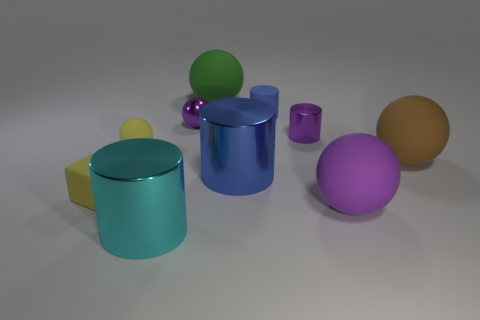There is a small rubber thing that is the same color as the small matte cube; what shape is it?
Give a very brief answer. Sphere. What shape is the tiny yellow thing that is in front of the big metal cylinder right of the large green matte thing?
Make the answer very short. Cube. Is there any other thing that is the same color as the tiny metal cylinder?
Keep it short and to the point. Yes. There is a blue object that is the same material as the green thing; what shape is it?
Provide a short and direct response. Cylinder. How big is the shiny object that is both on the left side of the blue metal object and to the right of the cyan shiny object?
Offer a very short reply. Small. There is a large rubber object on the left side of the big purple matte object; is its shape the same as the purple rubber object?
Keep it short and to the point. Yes. How big is the metal cylinder on the right side of the large metallic thing that is to the right of the tiny purple ball behind the large purple thing?
Ensure brevity in your answer.  Small. What size is the sphere that is the same color as the small cube?
Offer a very short reply. Small. How many objects are either large balls or cyan cylinders?
Provide a succinct answer. 4. There is a big thing that is left of the large purple matte thing and in front of the yellow rubber block; what shape is it?
Offer a very short reply. Cylinder. 